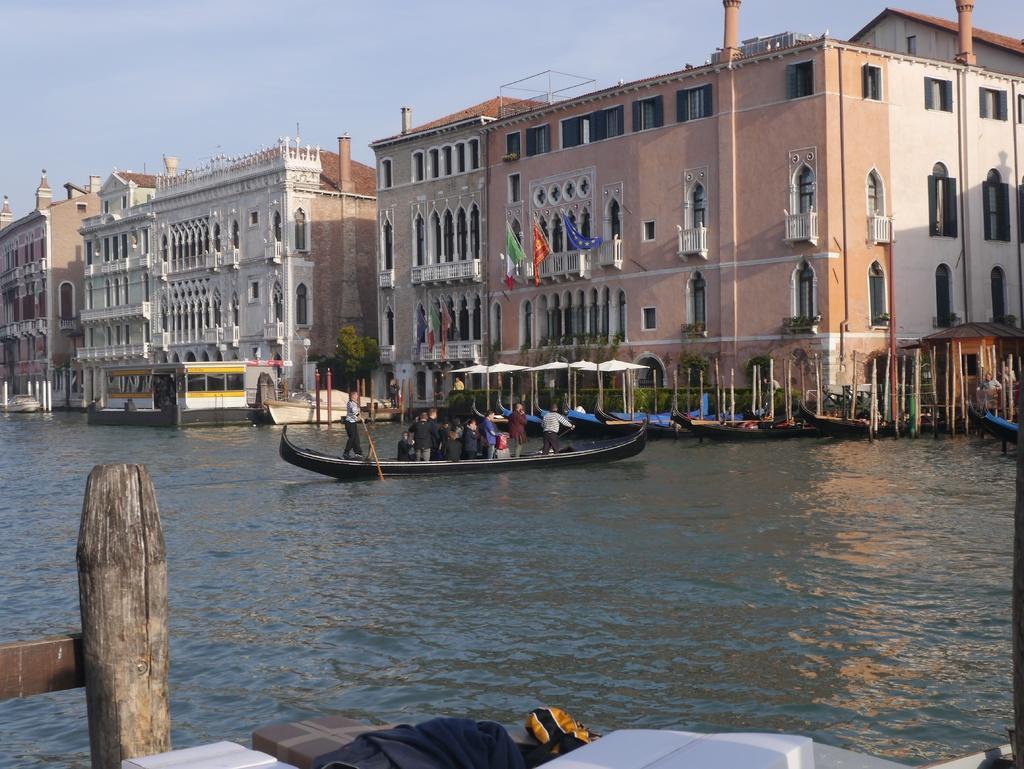Could you give a brief overview of what you see in this image? We can see clothes, wooden pole and water. There are people in a boat and we can see poles and boats. In the background we can see light on pole, buildings, trees, flags, tents and sky. 